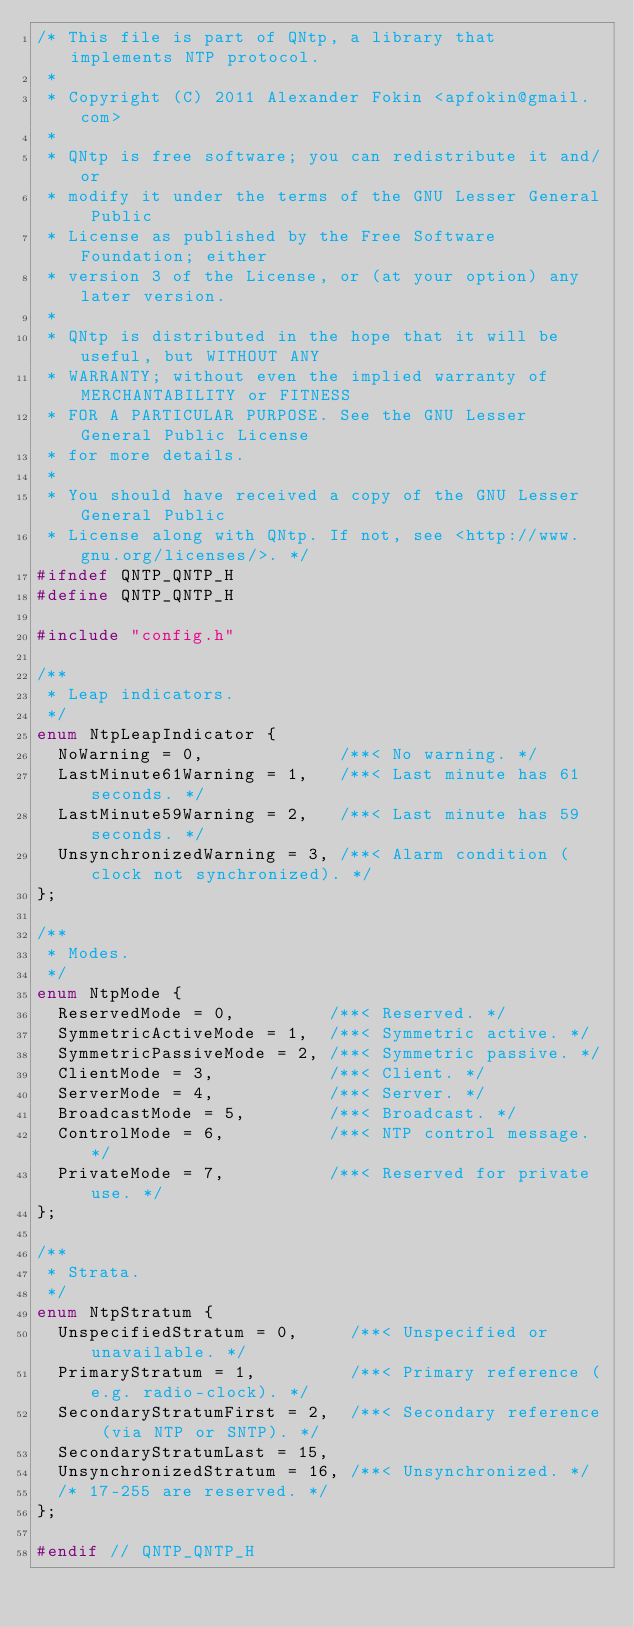Convert code to text. <code><loc_0><loc_0><loc_500><loc_500><_C_>/* This file is part of QNtp, a library that implements NTP protocol.
 *
 * Copyright (C) 2011 Alexander Fokin <apfokin@gmail.com>
 *
 * QNtp is free software; you can redistribute it and/or
 * modify it under the terms of the GNU Lesser General Public
 * License as published by the Free Software Foundation; either
 * version 3 of the License, or (at your option) any later version.
 *
 * QNtp is distributed in the hope that it will be useful, but WITHOUT ANY
 * WARRANTY; without even the implied warranty of MERCHANTABILITY or FITNESS
 * FOR A PARTICULAR PURPOSE. See the GNU Lesser General Public License 
 * for more details.
 *
 * You should have received a copy of the GNU Lesser General Public
 * License along with QNtp. If not, see <http://www.gnu.org/licenses/>. */
#ifndef QNTP_QNTP_H
#define QNTP_QNTP_H

#include "config.h"

/**
 * Leap indicators.
 */ 
enum NtpLeapIndicator {
  NoWarning = 0,             /**< No warning. */
  LastMinute61Warning = 1,   /**< Last minute has 61 seconds. */
  LastMinute59Warning = 2,   /**< Last minute has 59 seconds. */
  UnsynchronizedWarning = 3, /**< Alarm condition (clock not synchronized). */
};

/**
 * Modes.
 */
enum NtpMode {
  ReservedMode = 0,         /**< Reserved. */
  SymmetricActiveMode = 1,  /**< Symmetric active. */
  SymmetricPassiveMode = 2, /**< Symmetric passive. */
  ClientMode = 3,           /**< Client. */
  ServerMode = 4,           /**< Server. */
  BroadcastMode = 5,        /**< Broadcast. */
  ControlMode = 6,          /**< NTP control message. */
  PrivateMode = 7,          /**< Reserved for private use. */
};

/**
 * Strata.
 */
enum NtpStratum {
  UnspecifiedStratum = 0,     /**< Unspecified or unavailable. */
  PrimaryStratum = 1,         /**< Primary reference (e.g. radio-clock). */
  SecondaryStratumFirst = 2,  /**< Secondary reference (via NTP or SNTP). */
  SecondaryStratumLast = 15,
  UnsynchronizedStratum = 16, /**< Unsynchronized. */
  /* 17-255 are reserved. */
};

#endif // QNTP_QNTP_H
</code> 